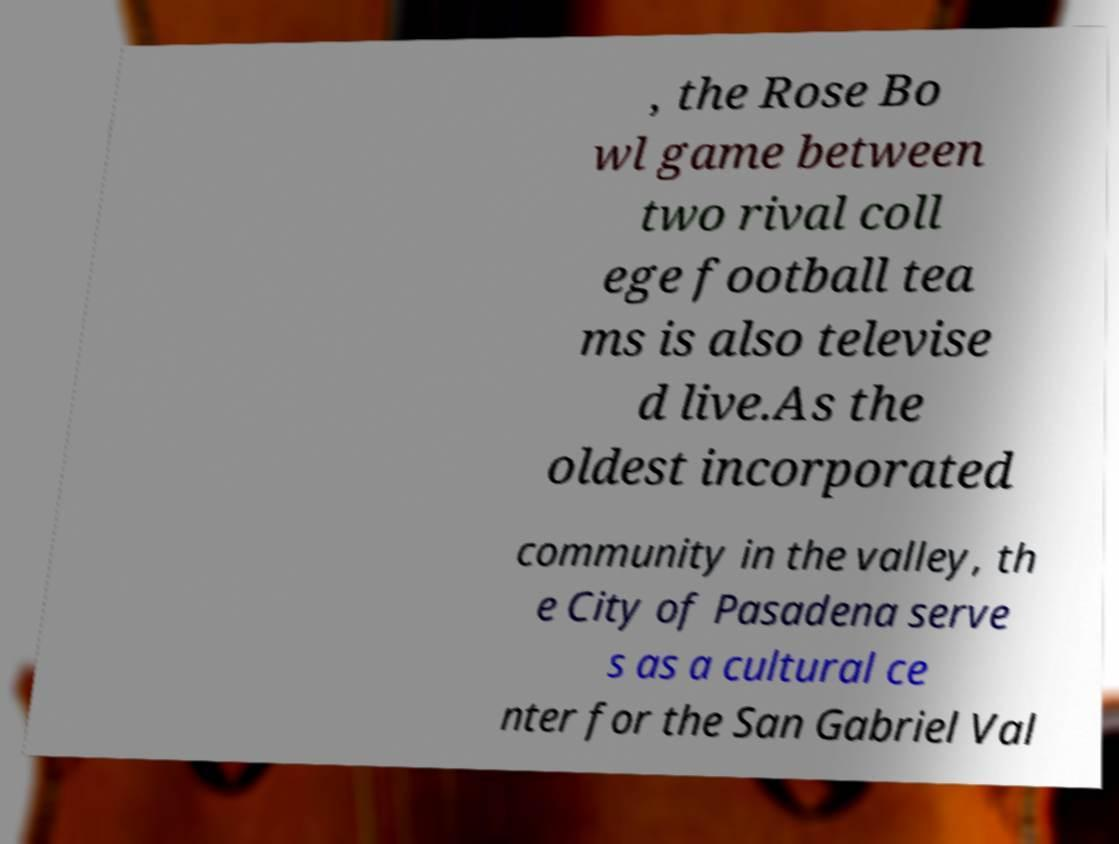Please identify and transcribe the text found in this image. , the Rose Bo wl game between two rival coll ege football tea ms is also televise d live.As the oldest incorporated community in the valley, th e City of Pasadena serve s as a cultural ce nter for the San Gabriel Val 